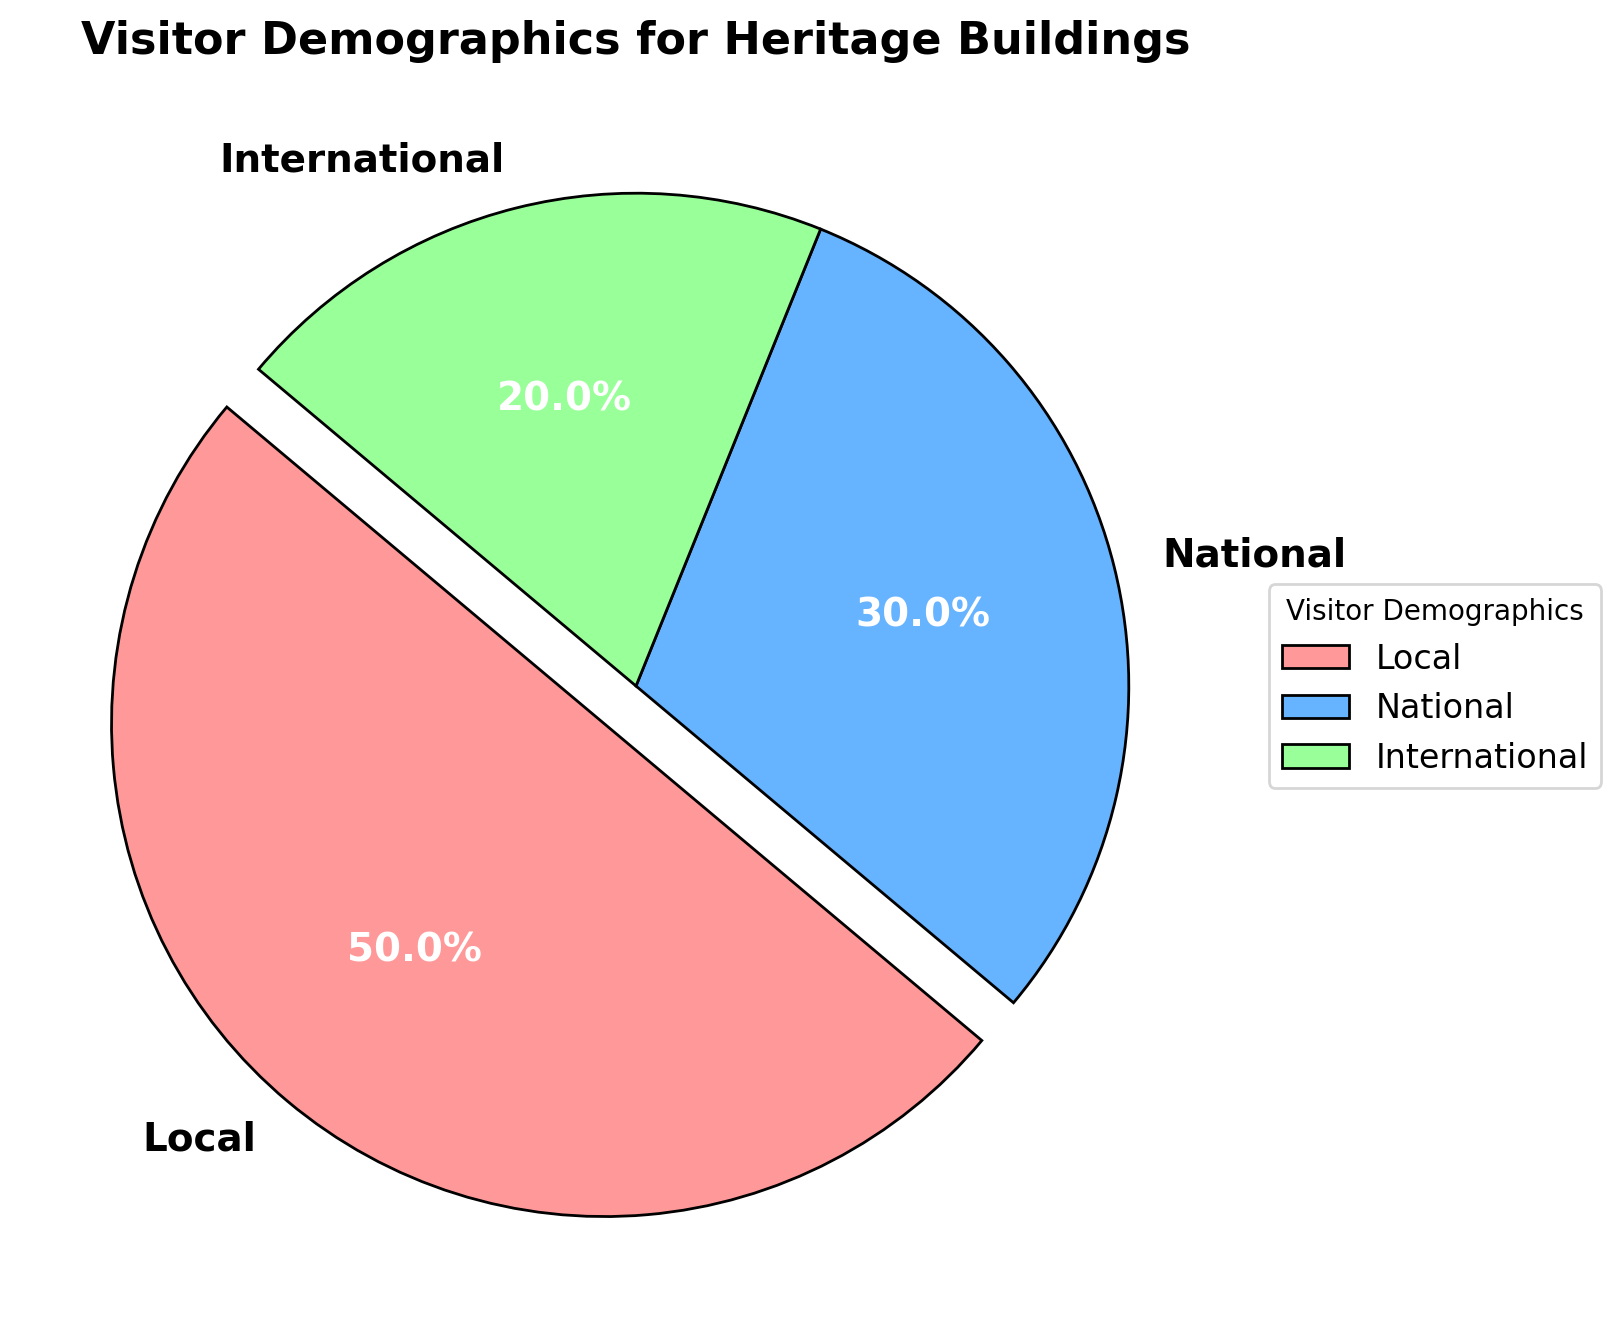What's the largest demographic group visiting the heritage buildings? The pie chart shows the relative proportions of visitor groups. The largest slice represents the "Local" visitors.
Answer: Local What's the total percentage of non-local visitors to the heritage buildings? To find the percentage of non-local visitors, sum the percentages of the "National" and "International" groups: 30% + 20% = 50%.
Answer: 50% Which visitor demographic group is represented by the green slice? Observing the pie chart, the green slice corresponds to the "International" visitor group.
Answer: International Which demographic group makes up twice the percentage of the smallest group? Comparing the percentages, "Local" visitors make up 50%, "National" visitors make up 30%, and "International" visitors make up 20%. "Local" is double the "International" group (20% * 2 = 40% is less than 50%).
Answer: Local Is the percentage of local visitors greater than the sum of national and international visitors? Sum of national and international visitors is 30% + 20% = 50%. Local visitors are 50%. 50% is equal to 50%.
Answer: No Which visitor group would contribute the second largest count of visitors? The pie chart's slices show the "National" group as the second largest after the "Local" group.
Answer: National What portion of the pie chart is exploded? The pie chart shows that only the "Local" segment is exploded.
Answer: Local Compare the percentage of national visitors to international visitors. The pie chart indicates "National" visitors are 30% and "International" visitors are 20%. 30% is greater than 20%.
Answer: National > International 